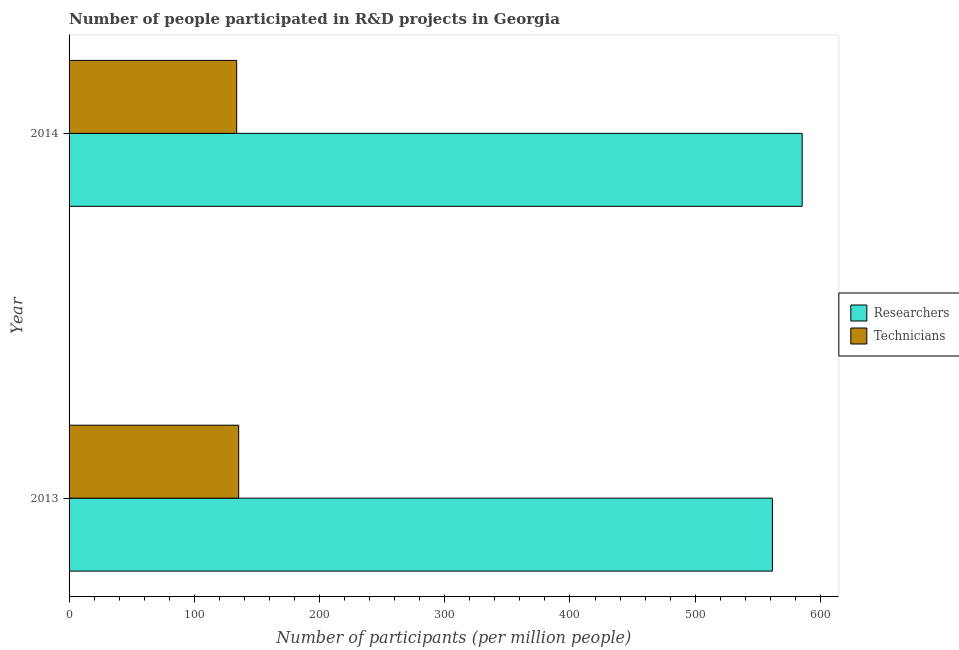How many different coloured bars are there?
Ensure brevity in your answer.  2. How many groups of bars are there?
Your answer should be very brief. 2. How many bars are there on the 2nd tick from the top?
Provide a succinct answer. 2. In how many cases, is the number of bars for a given year not equal to the number of legend labels?
Ensure brevity in your answer.  0. What is the number of researchers in 2014?
Keep it short and to the point. 585.41. Across all years, what is the maximum number of researchers?
Offer a very short reply. 585.41. Across all years, what is the minimum number of researchers?
Your answer should be very brief. 561.63. In which year was the number of technicians minimum?
Your answer should be very brief. 2014. What is the total number of technicians in the graph?
Ensure brevity in your answer.  269.29. What is the difference between the number of researchers in 2013 and that in 2014?
Provide a succinct answer. -23.78. What is the difference between the number of technicians in 2013 and the number of researchers in 2014?
Give a very brief answer. -449.96. What is the average number of technicians per year?
Ensure brevity in your answer.  134.64. In the year 2013, what is the difference between the number of technicians and number of researchers?
Your answer should be compact. -426.19. What is the ratio of the number of technicians in 2013 to that in 2014?
Your answer should be compact. 1.01. In how many years, is the number of technicians greater than the average number of technicians taken over all years?
Your response must be concise. 1. What does the 1st bar from the top in 2013 represents?
Provide a short and direct response. Technicians. What does the 2nd bar from the bottom in 2014 represents?
Offer a terse response. Technicians. What is the difference between two consecutive major ticks on the X-axis?
Give a very brief answer. 100. Are the values on the major ticks of X-axis written in scientific E-notation?
Make the answer very short. No. How many legend labels are there?
Ensure brevity in your answer.  2. How are the legend labels stacked?
Keep it short and to the point. Vertical. What is the title of the graph?
Provide a short and direct response. Number of people participated in R&D projects in Georgia. Does "Netherlands" appear as one of the legend labels in the graph?
Ensure brevity in your answer.  No. What is the label or title of the X-axis?
Offer a terse response. Number of participants (per million people). What is the label or title of the Y-axis?
Your answer should be very brief. Year. What is the Number of participants (per million people) of Researchers in 2013?
Your answer should be compact. 561.63. What is the Number of participants (per million people) of Technicians in 2013?
Ensure brevity in your answer.  135.45. What is the Number of participants (per million people) of Researchers in 2014?
Offer a terse response. 585.41. What is the Number of participants (per million people) of Technicians in 2014?
Your response must be concise. 133.84. Across all years, what is the maximum Number of participants (per million people) in Researchers?
Keep it short and to the point. 585.41. Across all years, what is the maximum Number of participants (per million people) of Technicians?
Provide a short and direct response. 135.45. Across all years, what is the minimum Number of participants (per million people) in Researchers?
Your answer should be very brief. 561.63. Across all years, what is the minimum Number of participants (per million people) in Technicians?
Offer a terse response. 133.84. What is the total Number of participants (per million people) in Researchers in the graph?
Give a very brief answer. 1147.05. What is the total Number of participants (per million people) in Technicians in the graph?
Keep it short and to the point. 269.29. What is the difference between the Number of participants (per million people) in Researchers in 2013 and that in 2014?
Provide a short and direct response. -23.78. What is the difference between the Number of participants (per million people) in Technicians in 2013 and that in 2014?
Provide a succinct answer. 1.61. What is the difference between the Number of participants (per million people) in Researchers in 2013 and the Number of participants (per million people) in Technicians in 2014?
Give a very brief answer. 427.8. What is the average Number of participants (per million people) in Researchers per year?
Offer a very short reply. 573.52. What is the average Number of participants (per million people) of Technicians per year?
Your answer should be very brief. 134.64. In the year 2013, what is the difference between the Number of participants (per million people) of Researchers and Number of participants (per million people) of Technicians?
Offer a very short reply. 426.19. In the year 2014, what is the difference between the Number of participants (per million people) in Researchers and Number of participants (per million people) in Technicians?
Provide a succinct answer. 451.57. What is the ratio of the Number of participants (per million people) in Researchers in 2013 to that in 2014?
Make the answer very short. 0.96. What is the ratio of the Number of participants (per million people) of Technicians in 2013 to that in 2014?
Keep it short and to the point. 1.01. What is the difference between the highest and the second highest Number of participants (per million people) of Researchers?
Your answer should be very brief. 23.78. What is the difference between the highest and the second highest Number of participants (per million people) in Technicians?
Offer a terse response. 1.61. What is the difference between the highest and the lowest Number of participants (per million people) in Researchers?
Provide a succinct answer. 23.78. What is the difference between the highest and the lowest Number of participants (per million people) in Technicians?
Keep it short and to the point. 1.61. 